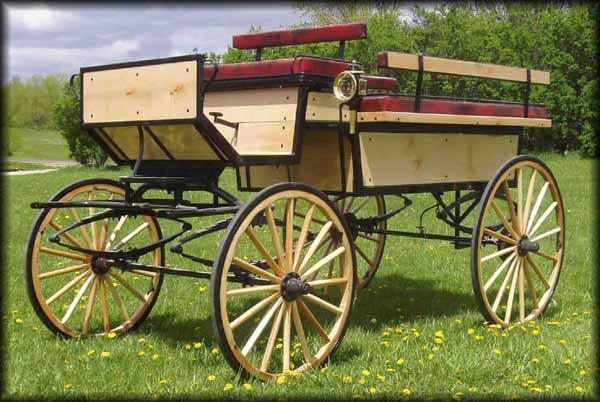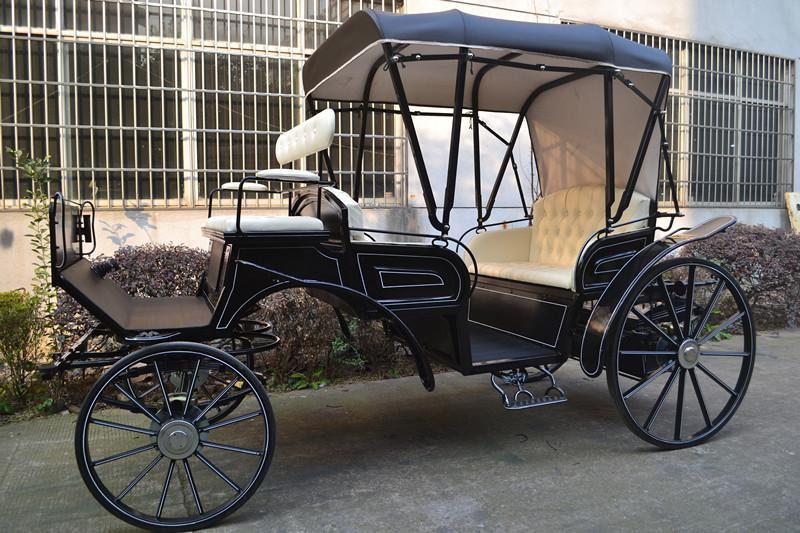The first image is the image on the left, the second image is the image on the right. For the images displayed, is the sentence "There is a total of two empty four wheel carts." factually correct? Answer yes or no. Yes. The first image is the image on the left, the second image is the image on the right. Given the left and right images, does the statement "The carriage in the right image is covered." hold true? Answer yes or no. Yes. 